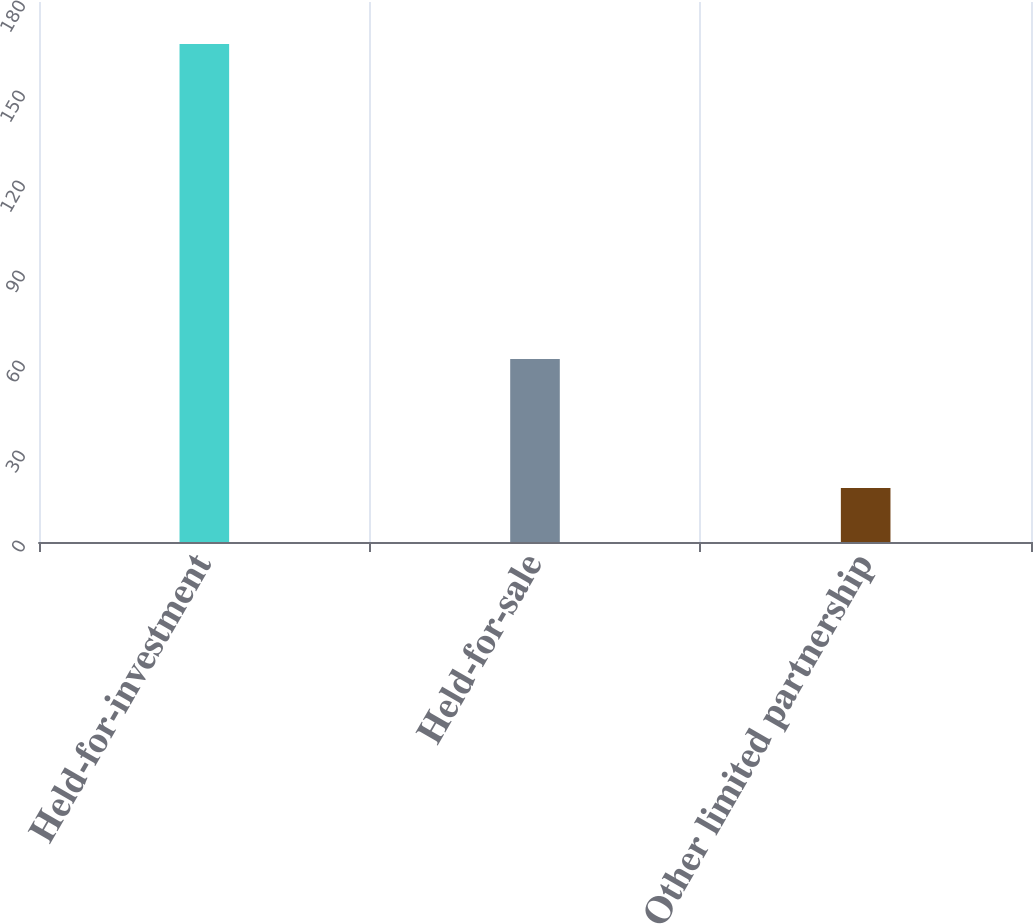<chart> <loc_0><loc_0><loc_500><loc_500><bar_chart><fcel>Held-for-investment<fcel>Held-for-sale<fcel>Other limited partnership<nl><fcel>166<fcel>61<fcel>18<nl></chart> 